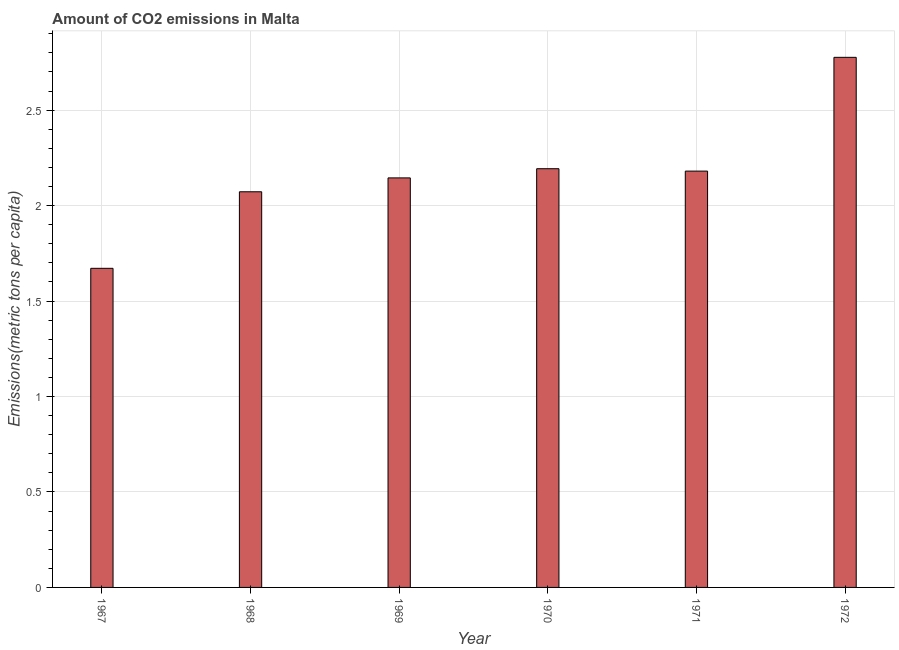Does the graph contain grids?
Make the answer very short. Yes. What is the title of the graph?
Offer a terse response. Amount of CO2 emissions in Malta. What is the label or title of the Y-axis?
Your answer should be compact. Emissions(metric tons per capita). What is the amount of co2 emissions in 1968?
Offer a very short reply. 2.07. Across all years, what is the maximum amount of co2 emissions?
Offer a very short reply. 2.78. Across all years, what is the minimum amount of co2 emissions?
Your answer should be compact. 1.67. In which year was the amount of co2 emissions minimum?
Provide a succinct answer. 1967. What is the sum of the amount of co2 emissions?
Offer a terse response. 13.04. What is the difference between the amount of co2 emissions in 1968 and 1969?
Ensure brevity in your answer.  -0.07. What is the average amount of co2 emissions per year?
Keep it short and to the point. 2.17. What is the median amount of co2 emissions?
Keep it short and to the point. 2.16. In how many years, is the amount of co2 emissions greater than 0.8 metric tons per capita?
Your answer should be compact. 6. Do a majority of the years between 1969 and 1970 (inclusive) have amount of co2 emissions greater than 0.8 metric tons per capita?
Make the answer very short. Yes. What is the ratio of the amount of co2 emissions in 1968 to that in 1971?
Make the answer very short. 0.95. Is the amount of co2 emissions in 1968 less than that in 1969?
Your answer should be very brief. Yes. What is the difference between the highest and the second highest amount of co2 emissions?
Provide a short and direct response. 0.58. Is the sum of the amount of co2 emissions in 1967 and 1968 greater than the maximum amount of co2 emissions across all years?
Keep it short and to the point. Yes. What is the difference between the highest and the lowest amount of co2 emissions?
Provide a short and direct response. 1.11. In how many years, is the amount of co2 emissions greater than the average amount of co2 emissions taken over all years?
Offer a very short reply. 3. Are all the bars in the graph horizontal?
Your response must be concise. No. How many years are there in the graph?
Offer a terse response. 6. What is the Emissions(metric tons per capita) of 1967?
Make the answer very short. 1.67. What is the Emissions(metric tons per capita) of 1968?
Provide a short and direct response. 2.07. What is the Emissions(metric tons per capita) in 1969?
Your answer should be very brief. 2.15. What is the Emissions(metric tons per capita) of 1970?
Ensure brevity in your answer.  2.19. What is the Emissions(metric tons per capita) in 1971?
Provide a short and direct response. 2.18. What is the Emissions(metric tons per capita) in 1972?
Your response must be concise. 2.78. What is the difference between the Emissions(metric tons per capita) in 1967 and 1968?
Ensure brevity in your answer.  -0.4. What is the difference between the Emissions(metric tons per capita) in 1967 and 1969?
Make the answer very short. -0.47. What is the difference between the Emissions(metric tons per capita) in 1967 and 1970?
Make the answer very short. -0.52. What is the difference between the Emissions(metric tons per capita) in 1967 and 1971?
Ensure brevity in your answer.  -0.51. What is the difference between the Emissions(metric tons per capita) in 1967 and 1972?
Give a very brief answer. -1.11. What is the difference between the Emissions(metric tons per capita) in 1968 and 1969?
Your answer should be compact. -0.07. What is the difference between the Emissions(metric tons per capita) in 1968 and 1970?
Provide a succinct answer. -0.12. What is the difference between the Emissions(metric tons per capita) in 1968 and 1971?
Provide a succinct answer. -0.11. What is the difference between the Emissions(metric tons per capita) in 1968 and 1972?
Your response must be concise. -0.7. What is the difference between the Emissions(metric tons per capita) in 1969 and 1970?
Provide a succinct answer. -0.05. What is the difference between the Emissions(metric tons per capita) in 1969 and 1971?
Offer a very short reply. -0.04. What is the difference between the Emissions(metric tons per capita) in 1969 and 1972?
Provide a succinct answer. -0.63. What is the difference between the Emissions(metric tons per capita) in 1970 and 1971?
Make the answer very short. 0.01. What is the difference between the Emissions(metric tons per capita) in 1970 and 1972?
Keep it short and to the point. -0.58. What is the difference between the Emissions(metric tons per capita) in 1971 and 1972?
Provide a succinct answer. -0.6. What is the ratio of the Emissions(metric tons per capita) in 1967 to that in 1968?
Keep it short and to the point. 0.81. What is the ratio of the Emissions(metric tons per capita) in 1967 to that in 1969?
Provide a short and direct response. 0.78. What is the ratio of the Emissions(metric tons per capita) in 1967 to that in 1970?
Make the answer very short. 0.76. What is the ratio of the Emissions(metric tons per capita) in 1967 to that in 1971?
Give a very brief answer. 0.77. What is the ratio of the Emissions(metric tons per capita) in 1967 to that in 1972?
Provide a succinct answer. 0.6. What is the ratio of the Emissions(metric tons per capita) in 1968 to that in 1970?
Provide a succinct answer. 0.94. What is the ratio of the Emissions(metric tons per capita) in 1968 to that in 1971?
Keep it short and to the point. 0.95. What is the ratio of the Emissions(metric tons per capita) in 1968 to that in 1972?
Make the answer very short. 0.75. What is the ratio of the Emissions(metric tons per capita) in 1969 to that in 1971?
Provide a short and direct response. 0.98. What is the ratio of the Emissions(metric tons per capita) in 1969 to that in 1972?
Give a very brief answer. 0.77. What is the ratio of the Emissions(metric tons per capita) in 1970 to that in 1971?
Give a very brief answer. 1.01. What is the ratio of the Emissions(metric tons per capita) in 1970 to that in 1972?
Make the answer very short. 0.79. What is the ratio of the Emissions(metric tons per capita) in 1971 to that in 1972?
Give a very brief answer. 0.79. 